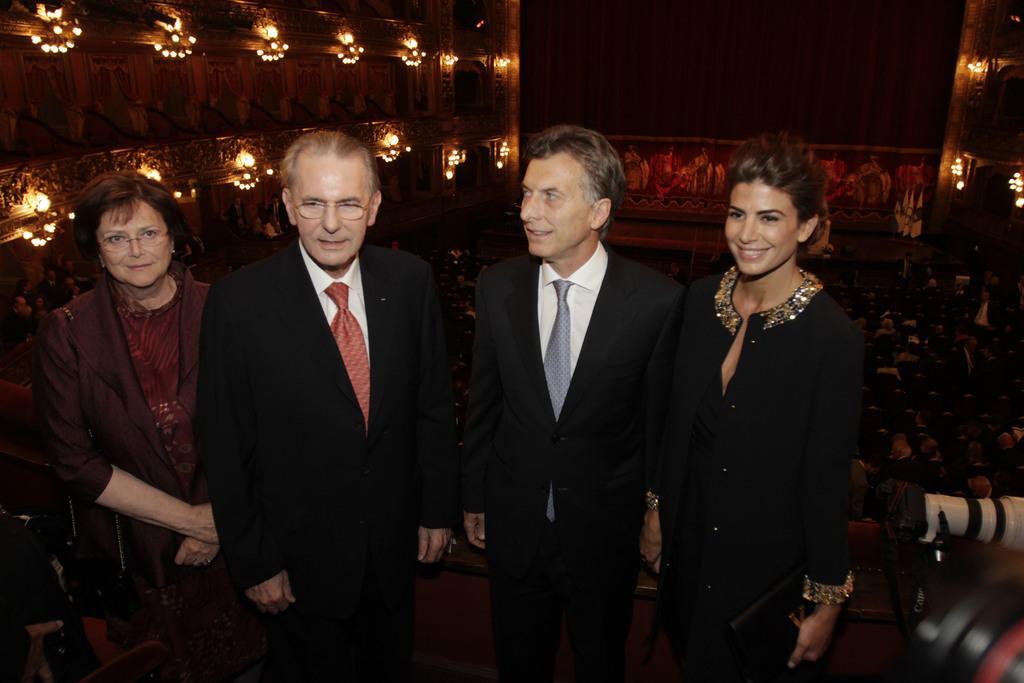How would you summarize this image in a sentence or two? In this image there are two women and two men standing and smiling. In the background we can see some people sitting. Image also consists of lights. 